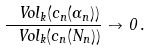<formula> <loc_0><loc_0><loc_500><loc_500>\frac { \ V o l _ { k } ( c _ { n } ( \Gamma _ { n } ) ) } { \ V o l _ { k } ( c _ { n } ( N _ { n } ) ) } \to 0 \, .</formula> 